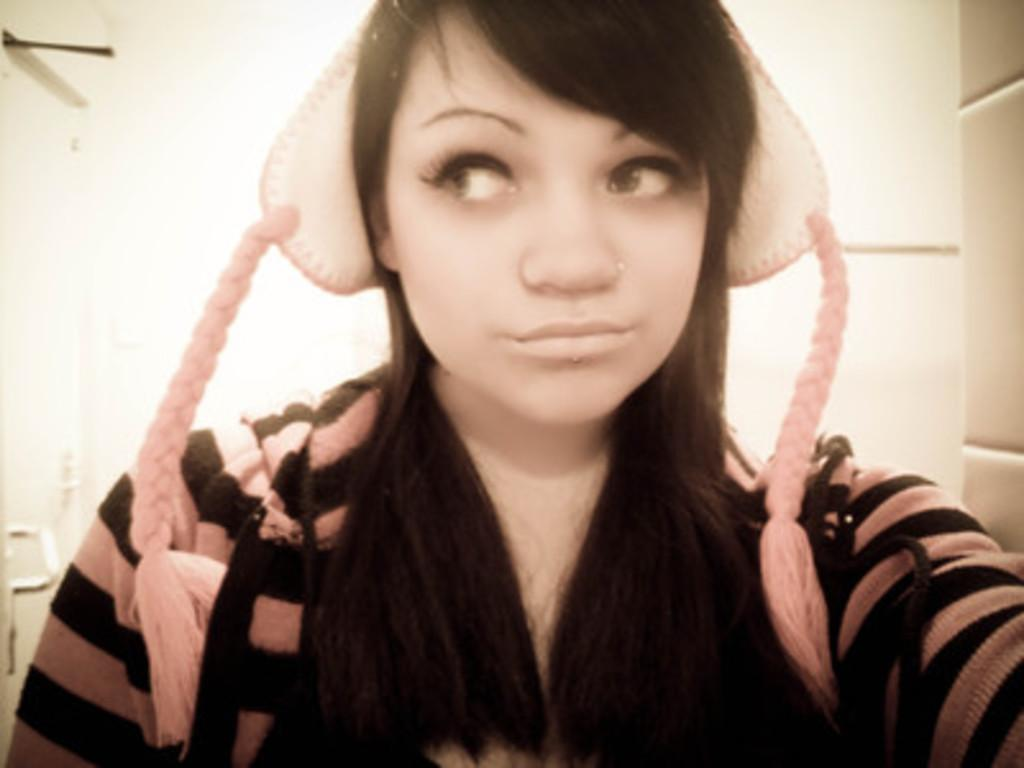Who is the main subject in the image? There is a girl in the image. What is the girl wearing on her head? The girl is wearing a cap. What can be seen in the background of the image? There is a wall in the background of the image. How many feet are visible in the image? There is no mention of feet in the image, so it is not possible to determine how many are visible. 